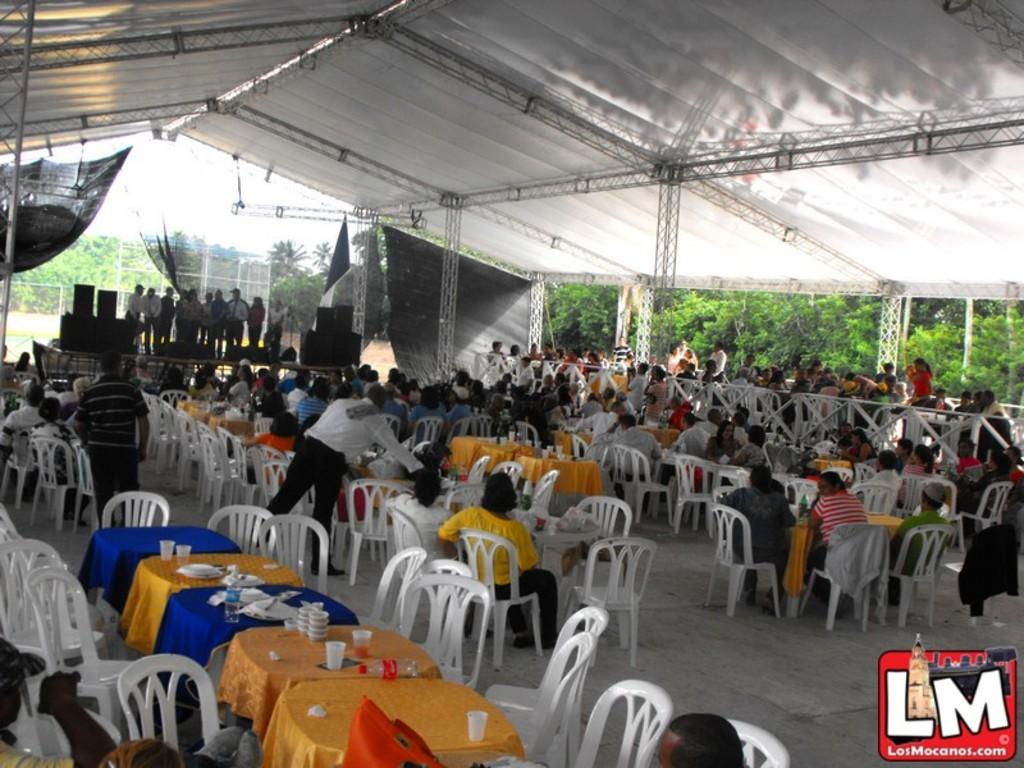What type of furniture is visible in the image? There are dining tables and chairs in the image. What are people doing while sitting on the furniture? People are sitting on the dining tables and chairs. What can be seen on the left side of the image? There is a stage on the left side of the image. What are people doing on the stage? People are standing on the stage. What color is the gold flower on the table in the image? There is no gold flower present in the image. Can you describe the cat sitting on the chair in the image? There is no cat present in the image. 